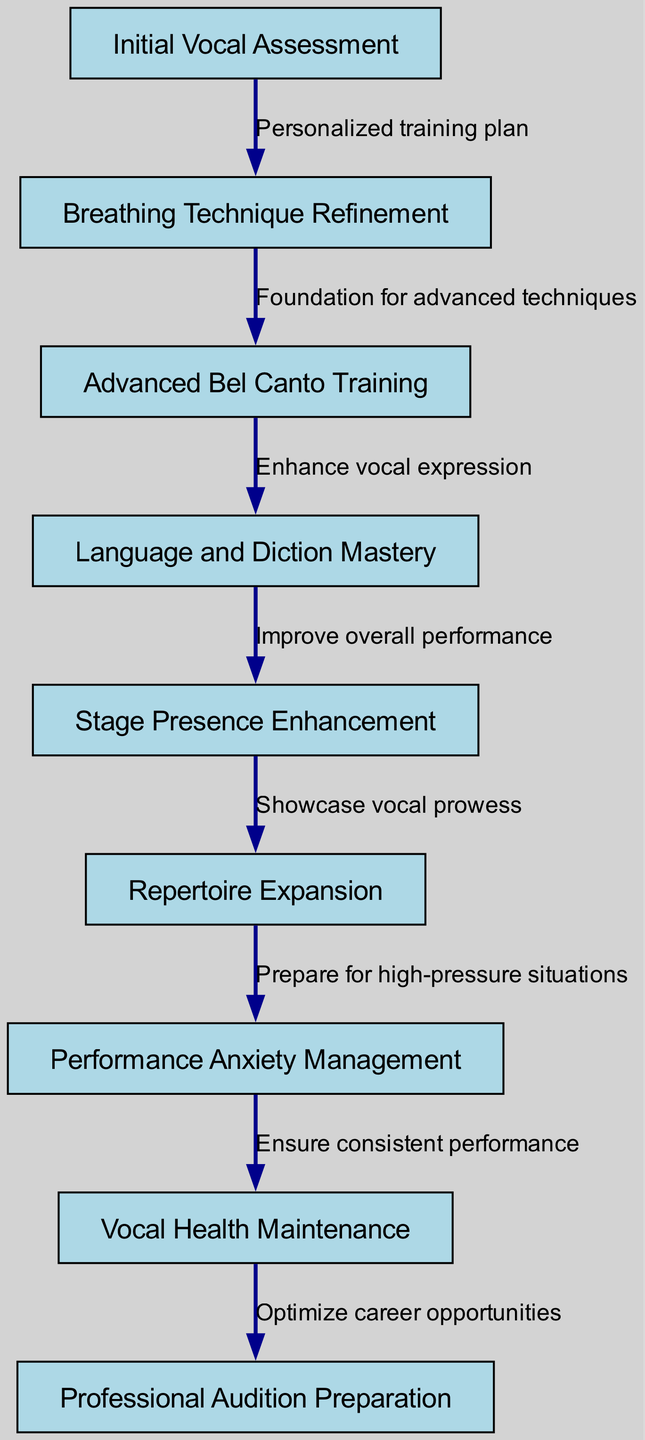What is the first step in the comprehensive vocal training program? The first step is labeled as "Initial Vocal Assessment," which is the starting point of the clinical pathway according to the diagram.
Answer: Initial Vocal Assessment How many nodes are there in total in the diagram? The diagram contains a total of 9 nodes as indicated in the data provided, representing various stages in the vocal training program.
Answer: 9 What is the relationship between "Breathing Technique Refinement" and "Advanced Bel Canto Training"? The arrow connecting these two nodes indicates a direct relationship, with "Breathing Technique Refinement" leading to "Advanced Bel Canto Training" as it provides the necessary foundation for advanced techniques.
Answer: Foundation for advanced techniques What step follows "Vocal Health Maintenance"? "Vocal Health Maintenance" leads directly to "Professional Audition Preparation," as it ensures that one is in optimal health to prepare for auditions.
Answer: Professional Audition Preparation What is the main focus of "Stage Presence Enhancement"? "Stage Presence Enhancement" focuses on improving overall performance, as indicated by the edge connecting it to the next node.
Answer: Improve overall performance Which node emphasizes the management of anxiety during performances? The node that emphasizes this is "Performance Anxiety Management," connecting to vital stages in the training sequence where mental readiness is crucial.
Answer: Performance Anxiety Management What is the final output of the training program based on the diagram? The final output, represented by the last node, is "Professional Audition Preparation," indicating that the training program prepares singers for actual auditions.
Answer: Professional Audition Preparation Which node is the precursor to "Language and Diction Mastery"? The diagram shows that "Advanced Bel Canto Training" is the direct precursor to "Language and Diction Mastery," enhancing vocal expression to aid in this skill.
Answer: Advanced Bel Canto Training How does "Repertoire Expansion" relate to performance anxiety? "Repertoire Expansion" prepares singers for high-pressure situations, as indicated by the edge leading to "Performance Anxiety Management," showing that a diverse repertoire can bolster confidence.
Answer: Prepare for high-pressure situations 